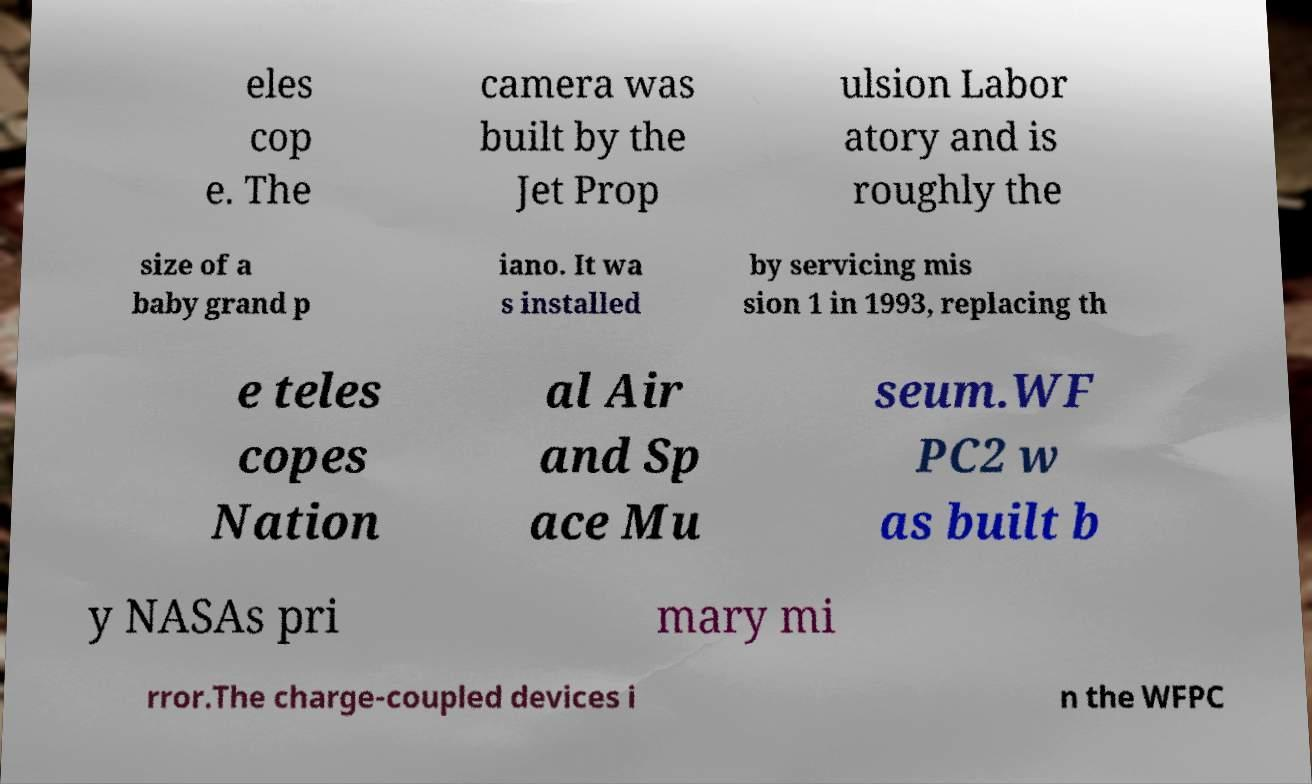Please identify and transcribe the text found in this image. eles cop e. The camera was built by the Jet Prop ulsion Labor atory and is roughly the size of a baby grand p iano. It wa s installed by servicing mis sion 1 in 1993, replacing th e teles copes Nation al Air and Sp ace Mu seum.WF PC2 w as built b y NASAs pri mary mi rror.The charge-coupled devices i n the WFPC 